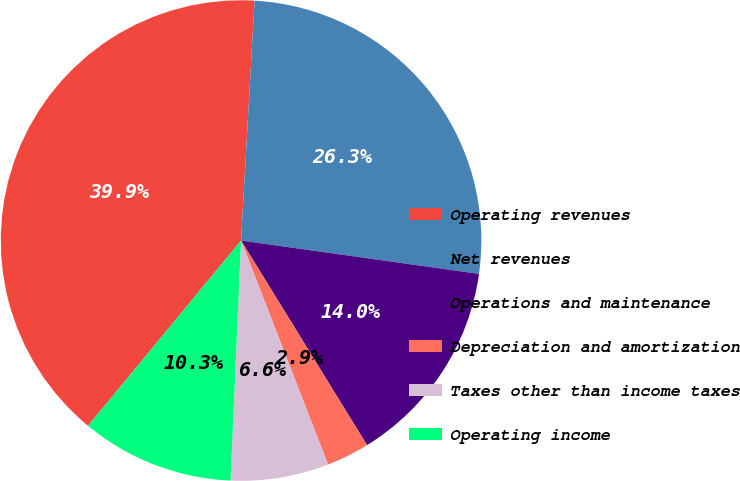Convert chart to OTSL. <chart><loc_0><loc_0><loc_500><loc_500><pie_chart><fcel>Operating revenues<fcel>Net revenues<fcel>Operations and maintenance<fcel>Depreciation and amortization<fcel>Taxes other than income taxes<fcel>Operating income<nl><fcel>39.91%<fcel>26.32%<fcel>14.0%<fcel>2.89%<fcel>6.59%<fcel>10.29%<nl></chart> 